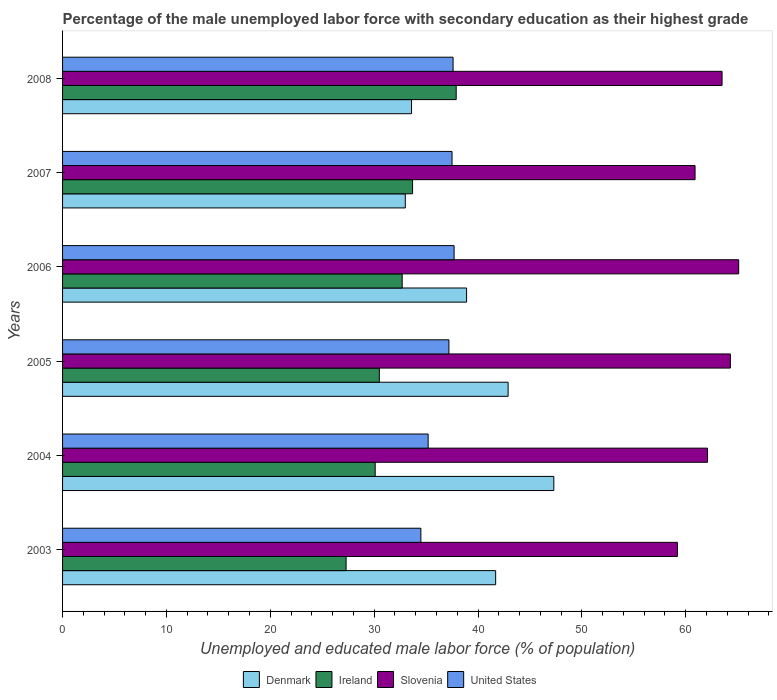How many bars are there on the 4th tick from the bottom?
Your answer should be compact. 4. What is the label of the 4th group of bars from the top?
Your answer should be compact. 2005. In how many cases, is the number of bars for a given year not equal to the number of legend labels?
Your answer should be compact. 0. What is the percentage of the unemployed male labor force with secondary education in Denmark in 2007?
Your response must be concise. 33. Across all years, what is the maximum percentage of the unemployed male labor force with secondary education in Denmark?
Your answer should be very brief. 47.3. Across all years, what is the minimum percentage of the unemployed male labor force with secondary education in Denmark?
Offer a terse response. 33. What is the total percentage of the unemployed male labor force with secondary education in Ireland in the graph?
Ensure brevity in your answer.  192.2. What is the difference between the percentage of the unemployed male labor force with secondary education in Denmark in 2004 and that in 2006?
Provide a short and direct response. 8.4. What is the difference between the percentage of the unemployed male labor force with secondary education in Slovenia in 2007 and the percentage of the unemployed male labor force with secondary education in United States in 2003?
Ensure brevity in your answer.  26.4. What is the average percentage of the unemployed male labor force with secondary education in Ireland per year?
Give a very brief answer. 32.03. In the year 2008, what is the difference between the percentage of the unemployed male labor force with secondary education in Denmark and percentage of the unemployed male labor force with secondary education in Ireland?
Offer a terse response. -4.3. In how many years, is the percentage of the unemployed male labor force with secondary education in Slovenia greater than 66 %?
Provide a succinct answer. 0. What is the ratio of the percentage of the unemployed male labor force with secondary education in Denmark in 2005 to that in 2006?
Provide a short and direct response. 1.1. Is the percentage of the unemployed male labor force with secondary education in Denmark in 2004 less than that in 2008?
Offer a very short reply. No. Is the difference between the percentage of the unemployed male labor force with secondary education in Denmark in 2004 and 2008 greater than the difference between the percentage of the unemployed male labor force with secondary education in Ireland in 2004 and 2008?
Your answer should be very brief. Yes. What is the difference between the highest and the second highest percentage of the unemployed male labor force with secondary education in United States?
Offer a very short reply. 0.1. What is the difference between the highest and the lowest percentage of the unemployed male labor force with secondary education in Slovenia?
Your answer should be compact. 5.9. In how many years, is the percentage of the unemployed male labor force with secondary education in Ireland greater than the average percentage of the unemployed male labor force with secondary education in Ireland taken over all years?
Provide a short and direct response. 3. Is it the case that in every year, the sum of the percentage of the unemployed male labor force with secondary education in Ireland and percentage of the unemployed male labor force with secondary education in Denmark is greater than the sum of percentage of the unemployed male labor force with secondary education in United States and percentage of the unemployed male labor force with secondary education in Slovenia?
Your response must be concise. No. What does the 3rd bar from the top in 2003 represents?
Offer a terse response. Ireland. What does the 2nd bar from the bottom in 2007 represents?
Provide a short and direct response. Ireland. How many years are there in the graph?
Provide a short and direct response. 6. Are the values on the major ticks of X-axis written in scientific E-notation?
Your answer should be compact. No. Does the graph contain grids?
Give a very brief answer. No. How many legend labels are there?
Provide a short and direct response. 4. How are the legend labels stacked?
Provide a succinct answer. Horizontal. What is the title of the graph?
Offer a terse response. Percentage of the male unemployed labor force with secondary education as their highest grade. Does "Australia" appear as one of the legend labels in the graph?
Your answer should be very brief. No. What is the label or title of the X-axis?
Provide a short and direct response. Unemployed and educated male labor force (% of population). What is the Unemployed and educated male labor force (% of population) in Denmark in 2003?
Your answer should be very brief. 41.7. What is the Unemployed and educated male labor force (% of population) of Ireland in 2003?
Your response must be concise. 27.3. What is the Unemployed and educated male labor force (% of population) in Slovenia in 2003?
Make the answer very short. 59.2. What is the Unemployed and educated male labor force (% of population) in United States in 2003?
Provide a short and direct response. 34.5. What is the Unemployed and educated male labor force (% of population) of Denmark in 2004?
Your answer should be compact. 47.3. What is the Unemployed and educated male labor force (% of population) of Ireland in 2004?
Offer a terse response. 30.1. What is the Unemployed and educated male labor force (% of population) of Slovenia in 2004?
Your answer should be compact. 62.1. What is the Unemployed and educated male labor force (% of population) in United States in 2004?
Your response must be concise. 35.2. What is the Unemployed and educated male labor force (% of population) of Denmark in 2005?
Provide a short and direct response. 42.9. What is the Unemployed and educated male labor force (% of population) in Ireland in 2005?
Provide a short and direct response. 30.5. What is the Unemployed and educated male labor force (% of population) in Slovenia in 2005?
Make the answer very short. 64.3. What is the Unemployed and educated male labor force (% of population) of United States in 2005?
Make the answer very short. 37.2. What is the Unemployed and educated male labor force (% of population) of Denmark in 2006?
Make the answer very short. 38.9. What is the Unemployed and educated male labor force (% of population) in Ireland in 2006?
Give a very brief answer. 32.7. What is the Unemployed and educated male labor force (% of population) of Slovenia in 2006?
Your answer should be compact. 65.1. What is the Unemployed and educated male labor force (% of population) of United States in 2006?
Your response must be concise. 37.7. What is the Unemployed and educated male labor force (% of population) of Denmark in 2007?
Offer a very short reply. 33. What is the Unemployed and educated male labor force (% of population) of Ireland in 2007?
Give a very brief answer. 33.7. What is the Unemployed and educated male labor force (% of population) of Slovenia in 2007?
Your response must be concise. 60.9. What is the Unemployed and educated male labor force (% of population) of United States in 2007?
Your response must be concise. 37.5. What is the Unemployed and educated male labor force (% of population) in Denmark in 2008?
Provide a short and direct response. 33.6. What is the Unemployed and educated male labor force (% of population) of Ireland in 2008?
Provide a succinct answer. 37.9. What is the Unemployed and educated male labor force (% of population) of Slovenia in 2008?
Offer a terse response. 63.5. What is the Unemployed and educated male labor force (% of population) of United States in 2008?
Make the answer very short. 37.6. Across all years, what is the maximum Unemployed and educated male labor force (% of population) in Denmark?
Provide a succinct answer. 47.3. Across all years, what is the maximum Unemployed and educated male labor force (% of population) in Ireland?
Offer a terse response. 37.9. Across all years, what is the maximum Unemployed and educated male labor force (% of population) of Slovenia?
Provide a succinct answer. 65.1. Across all years, what is the maximum Unemployed and educated male labor force (% of population) of United States?
Make the answer very short. 37.7. Across all years, what is the minimum Unemployed and educated male labor force (% of population) in Denmark?
Make the answer very short. 33. Across all years, what is the minimum Unemployed and educated male labor force (% of population) of Ireland?
Your answer should be very brief. 27.3. Across all years, what is the minimum Unemployed and educated male labor force (% of population) of Slovenia?
Offer a terse response. 59.2. Across all years, what is the minimum Unemployed and educated male labor force (% of population) of United States?
Provide a short and direct response. 34.5. What is the total Unemployed and educated male labor force (% of population) in Denmark in the graph?
Your response must be concise. 237.4. What is the total Unemployed and educated male labor force (% of population) in Ireland in the graph?
Offer a terse response. 192.2. What is the total Unemployed and educated male labor force (% of population) in Slovenia in the graph?
Give a very brief answer. 375.1. What is the total Unemployed and educated male labor force (% of population) of United States in the graph?
Provide a short and direct response. 219.7. What is the difference between the Unemployed and educated male labor force (% of population) in Ireland in 2003 and that in 2004?
Make the answer very short. -2.8. What is the difference between the Unemployed and educated male labor force (% of population) of United States in 2003 and that in 2004?
Offer a very short reply. -0.7. What is the difference between the Unemployed and educated male labor force (% of population) of Denmark in 2003 and that in 2006?
Keep it short and to the point. 2.8. What is the difference between the Unemployed and educated male labor force (% of population) of Denmark in 2003 and that in 2008?
Offer a very short reply. 8.1. What is the difference between the Unemployed and educated male labor force (% of population) in Slovenia in 2003 and that in 2008?
Your response must be concise. -4.3. What is the difference between the Unemployed and educated male labor force (% of population) in United States in 2004 and that in 2005?
Provide a short and direct response. -2. What is the difference between the Unemployed and educated male labor force (% of population) in Ireland in 2004 and that in 2006?
Provide a short and direct response. -2.6. What is the difference between the Unemployed and educated male labor force (% of population) in United States in 2004 and that in 2006?
Make the answer very short. -2.5. What is the difference between the Unemployed and educated male labor force (% of population) of Ireland in 2004 and that in 2007?
Offer a very short reply. -3.6. What is the difference between the Unemployed and educated male labor force (% of population) in Slovenia in 2004 and that in 2007?
Your answer should be compact. 1.2. What is the difference between the Unemployed and educated male labor force (% of population) in Ireland in 2004 and that in 2008?
Your answer should be compact. -7.8. What is the difference between the Unemployed and educated male labor force (% of population) in Slovenia in 2004 and that in 2008?
Offer a very short reply. -1.4. What is the difference between the Unemployed and educated male labor force (% of population) of Denmark in 2005 and that in 2006?
Keep it short and to the point. 4. What is the difference between the Unemployed and educated male labor force (% of population) in Ireland in 2005 and that in 2006?
Your response must be concise. -2.2. What is the difference between the Unemployed and educated male labor force (% of population) in United States in 2005 and that in 2006?
Provide a short and direct response. -0.5. What is the difference between the Unemployed and educated male labor force (% of population) of Slovenia in 2005 and that in 2007?
Your response must be concise. 3.4. What is the difference between the Unemployed and educated male labor force (% of population) of Denmark in 2005 and that in 2008?
Your response must be concise. 9.3. What is the difference between the Unemployed and educated male labor force (% of population) in United States in 2005 and that in 2008?
Your answer should be very brief. -0.4. What is the difference between the Unemployed and educated male labor force (% of population) of Ireland in 2006 and that in 2007?
Give a very brief answer. -1. What is the difference between the Unemployed and educated male labor force (% of population) of Denmark in 2006 and that in 2008?
Your answer should be very brief. 5.3. What is the difference between the Unemployed and educated male labor force (% of population) in Ireland in 2006 and that in 2008?
Make the answer very short. -5.2. What is the difference between the Unemployed and educated male labor force (% of population) of Denmark in 2007 and that in 2008?
Give a very brief answer. -0.6. What is the difference between the Unemployed and educated male labor force (% of population) in United States in 2007 and that in 2008?
Provide a short and direct response. -0.1. What is the difference between the Unemployed and educated male labor force (% of population) of Denmark in 2003 and the Unemployed and educated male labor force (% of population) of Ireland in 2004?
Your answer should be compact. 11.6. What is the difference between the Unemployed and educated male labor force (% of population) in Denmark in 2003 and the Unemployed and educated male labor force (% of population) in Slovenia in 2004?
Offer a terse response. -20.4. What is the difference between the Unemployed and educated male labor force (% of population) of Denmark in 2003 and the Unemployed and educated male labor force (% of population) of United States in 2004?
Your response must be concise. 6.5. What is the difference between the Unemployed and educated male labor force (% of population) of Ireland in 2003 and the Unemployed and educated male labor force (% of population) of Slovenia in 2004?
Offer a very short reply. -34.8. What is the difference between the Unemployed and educated male labor force (% of population) of Slovenia in 2003 and the Unemployed and educated male labor force (% of population) of United States in 2004?
Give a very brief answer. 24. What is the difference between the Unemployed and educated male labor force (% of population) in Denmark in 2003 and the Unemployed and educated male labor force (% of population) in Ireland in 2005?
Ensure brevity in your answer.  11.2. What is the difference between the Unemployed and educated male labor force (% of population) in Denmark in 2003 and the Unemployed and educated male labor force (% of population) in Slovenia in 2005?
Give a very brief answer. -22.6. What is the difference between the Unemployed and educated male labor force (% of population) in Ireland in 2003 and the Unemployed and educated male labor force (% of population) in Slovenia in 2005?
Give a very brief answer. -37. What is the difference between the Unemployed and educated male labor force (% of population) of Ireland in 2003 and the Unemployed and educated male labor force (% of population) of United States in 2005?
Ensure brevity in your answer.  -9.9. What is the difference between the Unemployed and educated male labor force (% of population) of Slovenia in 2003 and the Unemployed and educated male labor force (% of population) of United States in 2005?
Provide a short and direct response. 22. What is the difference between the Unemployed and educated male labor force (% of population) of Denmark in 2003 and the Unemployed and educated male labor force (% of population) of Ireland in 2006?
Keep it short and to the point. 9. What is the difference between the Unemployed and educated male labor force (% of population) in Denmark in 2003 and the Unemployed and educated male labor force (% of population) in Slovenia in 2006?
Your answer should be compact. -23.4. What is the difference between the Unemployed and educated male labor force (% of population) in Ireland in 2003 and the Unemployed and educated male labor force (% of population) in Slovenia in 2006?
Your answer should be very brief. -37.8. What is the difference between the Unemployed and educated male labor force (% of population) of Ireland in 2003 and the Unemployed and educated male labor force (% of population) of United States in 2006?
Provide a short and direct response. -10.4. What is the difference between the Unemployed and educated male labor force (% of population) in Slovenia in 2003 and the Unemployed and educated male labor force (% of population) in United States in 2006?
Your response must be concise. 21.5. What is the difference between the Unemployed and educated male labor force (% of population) in Denmark in 2003 and the Unemployed and educated male labor force (% of population) in Ireland in 2007?
Keep it short and to the point. 8. What is the difference between the Unemployed and educated male labor force (% of population) in Denmark in 2003 and the Unemployed and educated male labor force (% of population) in Slovenia in 2007?
Make the answer very short. -19.2. What is the difference between the Unemployed and educated male labor force (% of population) of Denmark in 2003 and the Unemployed and educated male labor force (% of population) of United States in 2007?
Provide a short and direct response. 4.2. What is the difference between the Unemployed and educated male labor force (% of population) in Ireland in 2003 and the Unemployed and educated male labor force (% of population) in Slovenia in 2007?
Give a very brief answer. -33.6. What is the difference between the Unemployed and educated male labor force (% of population) in Ireland in 2003 and the Unemployed and educated male labor force (% of population) in United States in 2007?
Provide a succinct answer. -10.2. What is the difference between the Unemployed and educated male labor force (% of population) of Slovenia in 2003 and the Unemployed and educated male labor force (% of population) of United States in 2007?
Offer a very short reply. 21.7. What is the difference between the Unemployed and educated male labor force (% of population) of Denmark in 2003 and the Unemployed and educated male labor force (% of population) of Slovenia in 2008?
Make the answer very short. -21.8. What is the difference between the Unemployed and educated male labor force (% of population) in Ireland in 2003 and the Unemployed and educated male labor force (% of population) in Slovenia in 2008?
Your answer should be very brief. -36.2. What is the difference between the Unemployed and educated male labor force (% of population) of Slovenia in 2003 and the Unemployed and educated male labor force (% of population) of United States in 2008?
Your answer should be very brief. 21.6. What is the difference between the Unemployed and educated male labor force (% of population) in Denmark in 2004 and the Unemployed and educated male labor force (% of population) in Ireland in 2005?
Your answer should be compact. 16.8. What is the difference between the Unemployed and educated male labor force (% of population) of Denmark in 2004 and the Unemployed and educated male labor force (% of population) of Slovenia in 2005?
Your answer should be compact. -17. What is the difference between the Unemployed and educated male labor force (% of population) of Denmark in 2004 and the Unemployed and educated male labor force (% of population) of United States in 2005?
Provide a succinct answer. 10.1. What is the difference between the Unemployed and educated male labor force (% of population) in Ireland in 2004 and the Unemployed and educated male labor force (% of population) in Slovenia in 2005?
Your answer should be very brief. -34.2. What is the difference between the Unemployed and educated male labor force (% of population) in Ireland in 2004 and the Unemployed and educated male labor force (% of population) in United States in 2005?
Your response must be concise. -7.1. What is the difference between the Unemployed and educated male labor force (% of population) of Slovenia in 2004 and the Unemployed and educated male labor force (% of population) of United States in 2005?
Provide a short and direct response. 24.9. What is the difference between the Unemployed and educated male labor force (% of population) of Denmark in 2004 and the Unemployed and educated male labor force (% of population) of Slovenia in 2006?
Provide a short and direct response. -17.8. What is the difference between the Unemployed and educated male labor force (% of population) in Ireland in 2004 and the Unemployed and educated male labor force (% of population) in Slovenia in 2006?
Your answer should be compact. -35. What is the difference between the Unemployed and educated male labor force (% of population) of Ireland in 2004 and the Unemployed and educated male labor force (% of population) of United States in 2006?
Provide a succinct answer. -7.6. What is the difference between the Unemployed and educated male labor force (% of population) of Slovenia in 2004 and the Unemployed and educated male labor force (% of population) of United States in 2006?
Offer a terse response. 24.4. What is the difference between the Unemployed and educated male labor force (% of population) of Denmark in 2004 and the Unemployed and educated male labor force (% of population) of Ireland in 2007?
Make the answer very short. 13.6. What is the difference between the Unemployed and educated male labor force (% of population) of Ireland in 2004 and the Unemployed and educated male labor force (% of population) of Slovenia in 2007?
Offer a terse response. -30.8. What is the difference between the Unemployed and educated male labor force (% of population) in Ireland in 2004 and the Unemployed and educated male labor force (% of population) in United States in 2007?
Provide a short and direct response. -7.4. What is the difference between the Unemployed and educated male labor force (% of population) of Slovenia in 2004 and the Unemployed and educated male labor force (% of population) of United States in 2007?
Offer a very short reply. 24.6. What is the difference between the Unemployed and educated male labor force (% of population) of Denmark in 2004 and the Unemployed and educated male labor force (% of population) of Ireland in 2008?
Provide a succinct answer. 9.4. What is the difference between the Unemployed and educated male labor force (% of population) of Denmark in 2004 and the Unemployed and educated male labor force (% of population) of Slovenia in 2008?
Your response must be concise. -16.2. What is the difference between the Unemployed and educated male labor force (% of population) of Denmark in 2004 and the Unemployed and educated male labor force (% of population) of United States in 2008?
Keep it short and to the point. 9.7. What is the difference between the Unemployed and educated male labor force (% of population) of Ireland in 2004 and the Unemployed and educated male labor force (% of population) of Slovenia in 2008?
Provide a short and direct response. -33.4. What is the difference between the Unemployed and educated male labor force (% of population) in Denmark in 2005 and the Unemployed and educated male labor force (% of population) in Ireland in 2006?
Give a very brief answer. 10.2. What is the difference between the Unemployed and educated male labor force (% of population) in Denmark in 2005 and the Unemployed and educated male labor force (% of population) in Slovenia in 2006?
Keep it short and to the point. -22.2. What is the difference between the Unemployed and educated male labor force (% of population) of Ireland in 2005 and the Unemployed and educated male labor force (% of population) of Slovenia in 2006?
Ensure brevity in your answer.  -34.6. What is the difference between the Unemployed and educated male labor force (% of population) in Ireland in 2005 and the Unemployed and educated male labor force (% of population) in United States in 2006?
Your response must be concise. -7.2. What is the difference between the Unemployed and educated male labor force (% of population) in Slovenia in 2005 and the Unemployed and educated male labor force (% of population) in United States in 2006?
Provide a short and direct response. 26.6. What is the difference between the Unemployed and educated male labor force (% of population) of Denmark in 2005 and the Unemployed and educated male labor force (% of population) of Ireland in 2007?
Keep it short and to the point. 9.2. What is the difference between the Unemployed and educated male labor force (% of population) in Denmark in 2005 and the Unemployed and educated male labor force (% of population) in Slovenia in 2007?
Keep it short and to the point. -18. What is the difference between the Unemployed and educated male labor force (% of population) in Denmark in 2005 and the Unemployed and educated male labor force (% of population) in United States in 2007?
Keep it short and to the point. 5.4. What is the difference between the Unemployed and educated male labor force (% of population) of Ireland in 2005 and the Unemployed and educated male labor force (% of population) of Slovenia in 2007?
Keep it short and to the point. -30.4. What is the difference between the Unemployed and educated male labor force (% of population) of Slovenia in 2005 and the Unemployed and educated male labor force (% of population) of United States in 2007?
Make the answer very short. 26.8. What is the difference between the Unemployed and educated male labor force (% of population) of Denmark in 2005 and the Unemployed and educated male labor force (% of population) of Ireland in 2008?
Your response must be concise. 5. What is the difference between the Unemployed and educated male labor force (% of population) in Denmark in 2005 and the Unemployed and educated male labor force (% of population) in Slovenia in 2008?
Offer a terse response. -20.6. What is the difference between the Unemployed and educated male labor force (% of population) of Denmark in 2005 and the Unemployed and educated male labor force (% of population) of United States in 2008?
Ensure brevity in your answer.  5.3. What is the difference between the Unemployed and educated male labor force (% of population) of Ireland in 2005 and the Unemployed and educated male labor force (% of population) of Slovenia in 2008?
Your answer should be compact. -33. What is the difference between the Unemployed and educated male labor force (% of population) in Slovenia in 2005 and the Unemployed and educated male labor force (% of population) in United States in 2008?
Your answer should be compact. 26.7. What is the difference between the Unemployed and educated male labor force (% of population) in Denmark in 2006 and the Unemployed and educated male labor force (% of population) in Slovenia in 2007?
Your answer should be very brief. -22. What is the difference between the Unemployed and educated male labor force (% of population) in Denmark in 2006 and the Unemployed and educated male labor force (% of population) in United States in 2007?
Provide a short and direct response. 1.4. What is the difference between the Unemployed and educated male labor force (% of population) in Ireland in 2006 and the Unemployed and educated male labor force (% of population) in Slovenia in 2007?
Provide a succinct answer. -28.2. What is the difference between the Unemployed and educated male labor force (% of population) of Ireland in 2006 and the Unemployed and educated male labor force (% of population) of United States in 2007?
Give a very brief answer. -4.8. What is the difference between the Unemployed and educated male labor force (% of population) of Slovenia in 2006 and the Unemployed and educated male labor force (% of population) of United States in 2007?
Make the answer very short. 27.6. What is the difference between the Unemployed and educated male labor force (% of population) of Denmark in 2006 and the Unemployed and educated male labor force (% of population) of Ireland in 2008?
Your answer should be very brief. 1. What is the difference between the Unemployed and educated male labor force (% of population) in Denmark in 2006 and the Unemployed and educated male labor force (% of population) in Slovenia in 2008?
Ensure brevity in your answer.  -24.6. What is the difference between the Unemployed and educated male labor force (% of population) in Denmark in 2006 and the Unemployed and educated male labor force (% of population) in United States in 2008?
Make the answer very short. 1.3. What is the difference between the Unemployed and educated male labor force (% of population) of Ireland in 2006 and the Unemployed and educated male labor force (% of population) of Slovenia in 2008?
Ensure brevity in your answer.  -30.8. What is the difference between the Unemployed and educated male labor force (% of population) of Denmark in 2007 and the Unemployed and educated male labor force (% of population) of Slovenia in 2008?
Your response must be concise. -30.5. What is the difference between the Unemployed and educated male labor force (% of population) of Ireland in 2007 and the Unemployed and educated male labor force (% of population) of Slovenia in 2008?
Offer a very short reply. -29.8. What is the difference between the Unemployed and educated male labor force (% of population) of Slovenia in 2007 and the Unemployed and educated male labor force (% of population) of United States in 2008?
Provide a short and direct response. 23.3. What is the average Unemployed and educated male labor force (% of population) in Denmark per year?
Your answer should be very brief. 39.57. What is the average Unemployed and educated male labor force (% of population) in Ireland per year?
Your response must be concise. 32.03. What is the average Unemployed and educated male labor force (% of population) in Slovenia per year?
Ensure brevity in your answer.  62.52. What is the average Unemployed and educated male labor force (% of population) in United States per year?
Provide a succinct answer. 36.62. In the year 2003, what is the difference between the Unemployed and educated male labor force (% of population) in Denmark and Unemployed and educated male labor force (% of population) in Ireland?
Your answer should be compact. 14.4. In the year 2003, what is the difference between the Unemployed and educated male labor force (% of population) of Denmark and Unemployed and educated male labor force (% of population) of Slovenia?
Offer a terse response. -17.5. In the year 2003, what is the difference between the Unemployed and educated male labor force (% of population) in Ireland and Unemployed and educated male labor force (% of population) in Slovenia?
Offer a terse response. -31.9. In the year 2003, what is the difference between the Unemployed and educated male labor force (% of population) in Ireland and Unemployed and educated male labor force (% of population) in United States?
Keep it short and to the point. -7.2. In the year 2003, what is the difference between the Unemployed and educated male labor force (% of population) in Slovenia and Unemployed and educated male labor force (% of population) in United States?
Provide a succinct answer. 24.7. In the year 2004, what is the difference between the Unemployed and educated male labor force (% of population) of Denmark and Unemployed and educated male labor force (% of population) of Ireland?
Provide a short and direct response. 17.2. In the year 2004, what is the difference between the Unemployed and educated male labor force (% of population) of Denmark and Unemployed and educated male labor force (% of population) of Slovenia?
Ensure brevity in your answer.  -14.8. In the year 2004, what is the difference between the Unemployed and educated male labor force (% of population) in Denmark and Unemployed and educated male labor force (% of population) in United States?
Your answer should be very brief. 12.1. In the year 2004, what is the difference between the Unemployed and educated male labor force (% of population) in Ireland and Unemployed and educated male labor force (% of population) in Slovenia?
Give a very brief answer. -32. In the year 2004, what is the difference between the Unemployed and educated male labor force (% of population) of Ireland and Unemployed and educated male labor force (% of population) of United States?
Give a very brief answer. -5.1. In the year 2004, what is the difference between the Unemployed and educated male labor force (% of population) of Slovenia and Unemployed and educated male labor force (% of population) of United States?
Make the answer very short. 26.9. In the year 2005, what is the difference between the Unemployed and educated male labor force (% of population) in Denmark and Unemployed and educated male labor force (% of population) in Ireland?
Provide a succinct answer. 12.4. In the year 2005, what is the difference between the Unemployed and educated male labor force (% of population) in Denmark and Unemployed and educated male labor force (% of population) in Slovenia?
Offer a terse response. -21.4. In the year 2005, what is the difference between the Unemployed and educated male labor force (% of population) in Ireland and Unemployed and educated male labor force (% of population) in Slovenia?
Offer a terse response. -33.8. In the year 2005, what is the difference between the Unemployed and educated male labor force (% of population) in Ireland and Unemployed and educated male labor force (% of population) in United States?
Your answer should be compact. -6.7. In the year 2005, what is the difference between the Unemployed and educated male labor force (% of population) of Slovenia and Unemployed and educated male labor force (% of population) of United States?
Provide a succinct answer. 27.1. In the year 2006, what is the difference between the Unemployed and educated male labor force (% of population) in Denmark and Unemployed and educated male labor force (% of population) in Ireland?
Provide a succinct answer. 6.2. In the year 2006, what is the difference between the Unemployed and educated male labor force (% of population) of Denmark and Unemployed and educated male labor force (% of population) of Slovenia?
Offer a terse response. -26.2. In the year 2006, what is the difference between the Unemployed and educated male labor force (% of population) of Denmark and Unemployed and educated male labor force (% of population) of United States?
Your response must be concise. 1.2. In the year 2006, what is the difference between the Unemployed and educated male labor force (% of population) of Ireland and Unemployed and educated male labor force (% of population) of Slovenia?
Keep it short and to the point. -32.4. In the year 2006, what is the difference between the Unemployed and educated male labor force (% of population) in Slovenia and Unemployed and educated male labor force (% of population) in United States?
Keep it short and to the point. 27.4. In the year 2007, what is the difference between the Unemployed and educated male labor force (% of population) of Denmark and Unemployed and educated male labor force (% of population) of Slovenia?
Your response must be concise. -27.9. In the year 2007, what is the difference between the Unemployed and educated male labor force (% of population) of Denmark and Unemployed and educated male labor force (% of population) of United States?
Your answer should be compact. -4.5. In the year 2007, what is the difference between the Unemployed and educated male labor force (% of population) in Ireland and Unemployed and educated male labor force (% of population) in Slovenia?
Keep it short and to the point. -27.2. In the year 2007, what is the difference between the Unemployed and educated male labor force (% of population) in Ireland and Unemployed and educated male labor force (% of population) in United States?
Keep it short and to the point. -3.8. In the year 2007, what is the difference between the Unemployed and educated male labor force (% of population) of Slovenia and Unemployed and educated male labor force (% of population) of United States?
Ensure brevity in your answer.  23.4. In the year 2008, what is the difference between the Unemployed and educated male labor force (% of population) in Denmark and Unemployed and educated male labor force (% of population) in Slovenia?
Keep it short and to the point. -29.9. In the year 2008, what is the difference between the Unemployed and educated male labor force (% of population) in Denmark and Unemployed and educated male labor force (% of population) in United States?
Keep it short and to the point. -4. In the year 2008, what is the difference between the Unemployed and educated male labor force (% of population) in Ireland and Unemployed and educated male labor force (% of population) in Slovenia?
Make the answer very short. -25.6. In the year 2008, what is the difference between the Unemployed and educated male labor force (% of population) of Slovenia and Unemployed and educated male labor force (% of population) of United States?
Your answer should be compact. 25.9. What is the ratio of the Unemployed and educated male labor force (% of population) in Denmark in 2003 to that in 2004?
Provide a succinct answer. 0.88. What is the ratio of the Unemployed and educated male labor force (% of population) in Ireland in 2003 to that in 2004?
Offer a very short reply. 0.91. What is the ratio of the Unemployed and educated male labor force (% of population) of Slovenia in 2003 to that in 2004?
Your answer should be very brief. 0.95. What is the ratio of the Unemployed and educated male labor force (% of population) in United States in 2003 to that in 2004?
Provide a short and direct response. 0.98. What is the ratio of the Unemployed and educated male labor force (% of population) in Denmark in 2003 to that in 2005?
Offer a terse response. 0.97. What is the ratio of the Unemployed and educated male labor force (% of population) of Ireland in 2003 to that in 2005?
Your answer should be compact. 0.9. What is the ratio of the Unemployed and educated male labor force (% of population) in Slovenia in 2003 to that in 2005?
Provide a short and direct response. 0.92. What is the ratio of the Unemployed and educated male labor force (% of population) in United States in 2003 to that in 2005?
Make the answer very short. 0.93. What is the ratio of the Unemployed and educated male labor force (% of population) in Denmark in 2003 to that in 2006?
Offer a very short reply. 1.07. What is the ratio of the Unemployed and educated male labor force (% of population) of Ireland in 2003 to that in 2006?
Ensure brevity in your answer.  0.83. What is the ratio of the Unemployed and educated male labor force (% of population) of Slovenia in 2003 to that in 2006?
Ensure brevity in your answer.  0.91. What is the ratio of the Unemployed and educated male labor force (% of population) of United States in 2003 to that in 2006?
Provide a short and direct response. 0.92. What is the ratio of the Unemployed and educated male labor force (% of population) of Denmark in 2003 to that in 2007?
Provide a succinct answer. 1.26. What is the ratio of the Unemployed and educated male labor force (% of population) of Ireland in 2003 to that in 2007?
Provide a short and direct response. 0.81. What is the ratio of the Unemployed and educated male labor force (% of population) in Slovenia in 2003 to that in 2007?
Give a very brief answer. 0.97. What is the ratio of the Unemployed and educated male labor force (% of population) of Denmark in 2003 to that in 2008?
Provide a short and direct response. 1.24. What is the ratio of the Unemployed and educated male labor force (% of population) in Ireland in 2003 to that in 2008?
Give a very brief answer. 0.72. What is the ratio of the Unemployed and educated male labor force (% of population) in Slovenia in 2003 to that in 2008?
Your answer should be very brief. 0.93. What is the ratio of the Unemployed and educated male labor force (% of population) in United States in 2003 to that in 2008?
Keep it short and to the point. 0.92. What is the ratio of the Unemployed and educated male labor force (% of population) in Denmark in 2004 to that in 2005?
Offer a very short reply. 1.1. What is the ratio of the Unemployed and educated male labor force (% of population) of Ireland in 2004 to that in 2005?
Provide a succinct answer. 0.99. What is the ratio of the Unemployed and educated male labor force (% of population) of Slovenia in 2004 to that in 2005?
Your response must be concise. 0.97. What is the ratio of the Unemployed and educated male labor force (% of population) in United States in 2004 to that in 2005?
Make the answer very short. 0.95. What is the ratio of the Unemployed and educated male labor force (% of population) in Denmark in 2004 to that in 2006?
Make the answer very short. 1.22. What is the ratio of the Unemployed and educated male labor force (% of population) of Ireland in 2004 to that in 2006?
Offer a terse response. 0.92. What is the ratio of the Unemployed and educated male labor force (% of population) of Slovenia in 2004 to that in 2006?
Ensure brevity in your answer.  0.95. What is the ratio of the Unemployed and educated male labor force (% of population) in United States in 2004 to that in 2006?
Offer a terse response. 0.93. What is the ratio of the Unemployed and educated male labor force (% of population) of Denmark in 2004 to that in 2007?
Give a very brief answer. 1.43. What is the ratio of the Unemployed and educated male labor force (% of population) in Ireland in 2004 to that in 2007?
Offer a very short reply. 0.89. What is the ratio of the Unemployed and educated male labor force (% of population) in Slovenia in 2004 to that in 2007?
Offer a terse response. 1.02. What is the ratio of the Unemployed and educated male labor force (% of population) in United States in 2004 to that in 2007?
Give a very brief answer. 0.94. What is the ratio of the Unemployed and educated male labor force (% of population) in Denmark in 2004 to that in 2008?
Offer a very short reply. 1.41. What is the ratio of the Unemployed and educated male labor force (% of population) in Ireland in 2004 to that in 2008?
Offer a terse response. 0.79. What is the ratio of the Unemployed and educated male labor force (% of population) in United States in 2004 to that in 2008?
Provide a succinct answer. 0.94. What is the ratio of the Unemployed and educated male labor force (% of population) of Denmark in 2005 to that in 2006?
Your answer should be compact. 1.1. What is the ratio of the Unemployed and educated male labor force (% of population) in Ireland in 2005 to that in 2006?
Your response must be concise. 0.93. What is the ratio of the Unemployed and educated male labor force (% of population) of Slovenia in 2005 to that in 2006?
Keep it short and to the point. 0.99. What is the ratio of the Unemployed and educated male labor force (% of population) of United States in 2005 to that in 2006?
Ensure brevity in your answer.  0.99. What is the ratio of the Unemployed and educated male labor force (% of population) of Denmark in 2005 to that in 2007?
Ensure brevity in your answer.  1.3. What is the ratio of the Unemployed and educated male labor force (% of population) of Ireland in 2005 to that in 2007?
Make the answer very short. 0.91. What is the ratio of the Unemployed and educated male labor force (% of population) of Slovenia in 2005 to that in 2007?
Keep it short and to the point. 1.06. What is the ratio of the Unemployed and educated male labor force (% of population) of Denmark in 2005 to that in 2008?
Your response must be concise. 1.28. What is the ratio of the Unemployed and educated male labor force (% of population) of Ireland in 2005 to that in 2008?
Offer a very short reply. 0.8. What is the ratio of the Unemployed and educated male labor force (% of population) in Slovenia in 2005 to that in 2008?
Your response must be concise. 1.01. What is the ratio of the Unemployed and educated male labor force (% of population) in Denmark in 2006 to that in 2007?
Your response must be concise. 1.18. What is the ratio of the Unemployed and educated male labor force (% of population) of Ireland in 2006 to that in 2007?
Make the answer very short. 0.97. What is the ratio of the Unemployed and educated male labor force (% of population) in Slovenia in 2006 to that in 2007?
Make the answer very short. 1.07. What is the ratio of the Unemployed and educated male labor force (% of population) of Denmark in 2006 to that in 2008?
Ensure brevity in your answer.  1.16. What is the ratio of the Unemployed and educated male labor force (% of population) in Ireland in 2006 to that in 2008?
Give a very brief answer. 0.86. What is the ratio of the Unemployed and educated male labor force (% of population) of Slovenia in 2006 to that in 2008?
Make the answer very short. 1.03. What is the ratio of the Unemployed and educated male labor force (% of population) in United States in 2006 to that in 2008?
Ensure brevity in your answer.  1. What is the ratio of the Unemployed and educated male labor force (% of population) in Denmark in 2007 to that in 2008?
Your answer should be very brief. 0.98. What is the ratio of the Unemployed and educated male labor force (% of population) of Ireland in 2007 to that in 2008?
Offer a terse response. 0.89. What is the ratio of the Unemployed and educated male labor force (% of population) of Slovenia in 2007 to that in 2008?
Give a very brief answer. 0.96. What is the difference between the highest and the second highest Unemployed and educated male labor force (% of population) in Ireland?
Offer a very short reply. 4.2. What is the difference between the highest and the second highest Unemployed and educated male labor force (% of population) in United States?
Ensure brevity in your answer.  0.1. What is the difference between the highest and the lowest Unemployed and educated male labor force (% of population) of Denmark?
Your answer should be very brief. 14.3. 